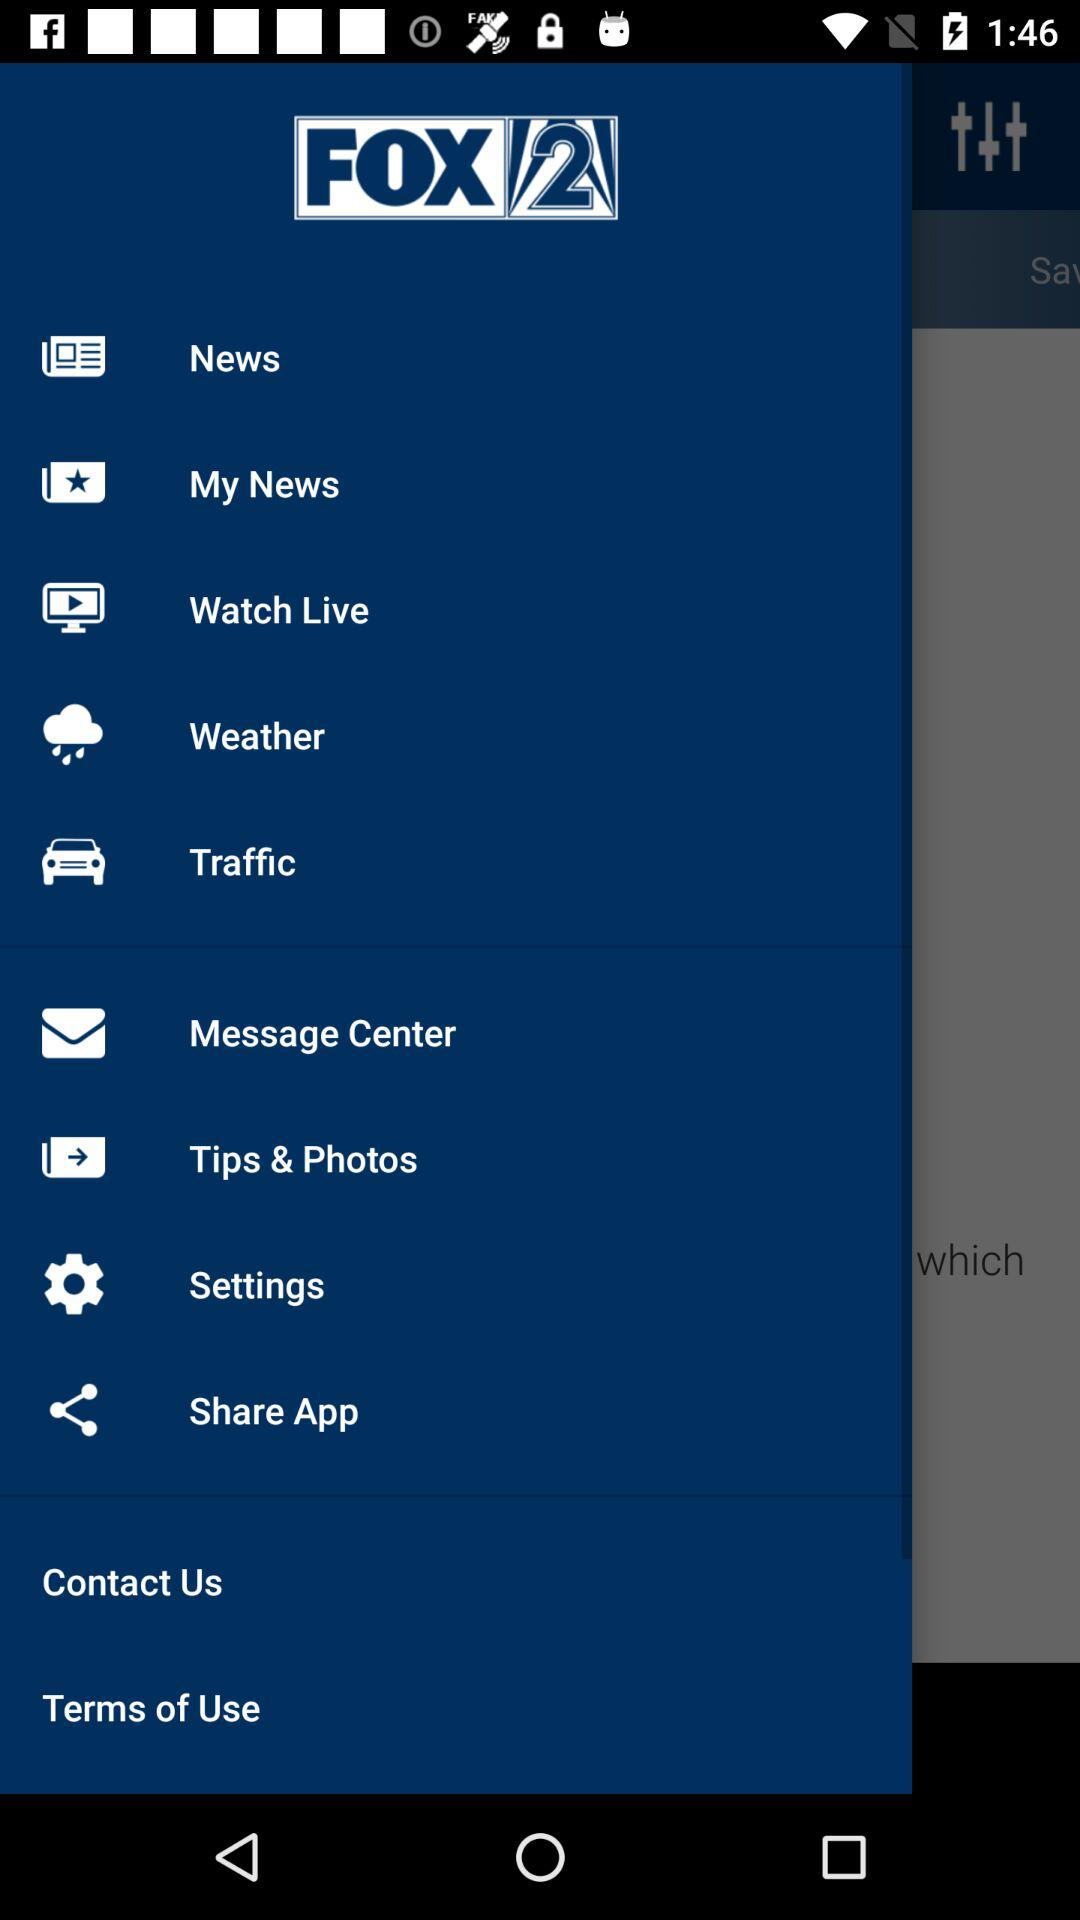What is the application name? The application name is "FOX 2". 